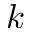<formula> <loc_0><loc_0><loc_500><loc_500>k</formula> 